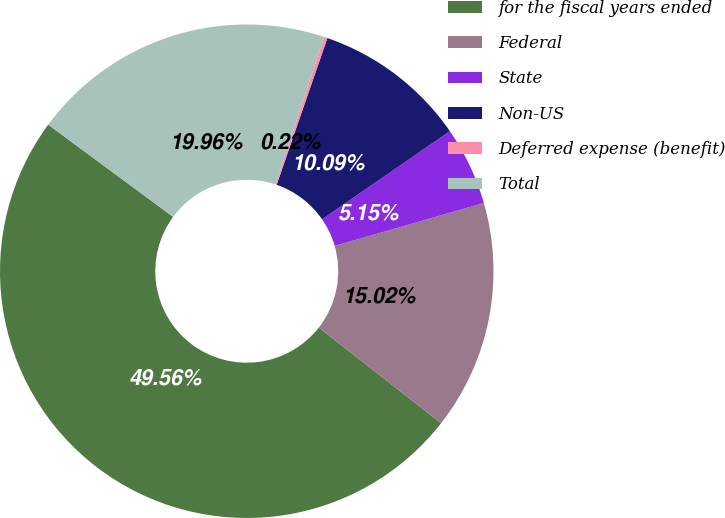Convert chart to OTSL. <chart><loc_0><loc_0><loc_500><loc_500><pie_chart><fcel>for the fiscal years ended<fcel>Federal<fcel>State<fcel>Non-US<fcel>Deferred expense (benefit)<fcel>Total<nl><fcel>49.56%<fcel>15.02%<fcel>5.15%<fcel>10.09%<fcel>0.22%<fcel>19.96%<nl></chart> 